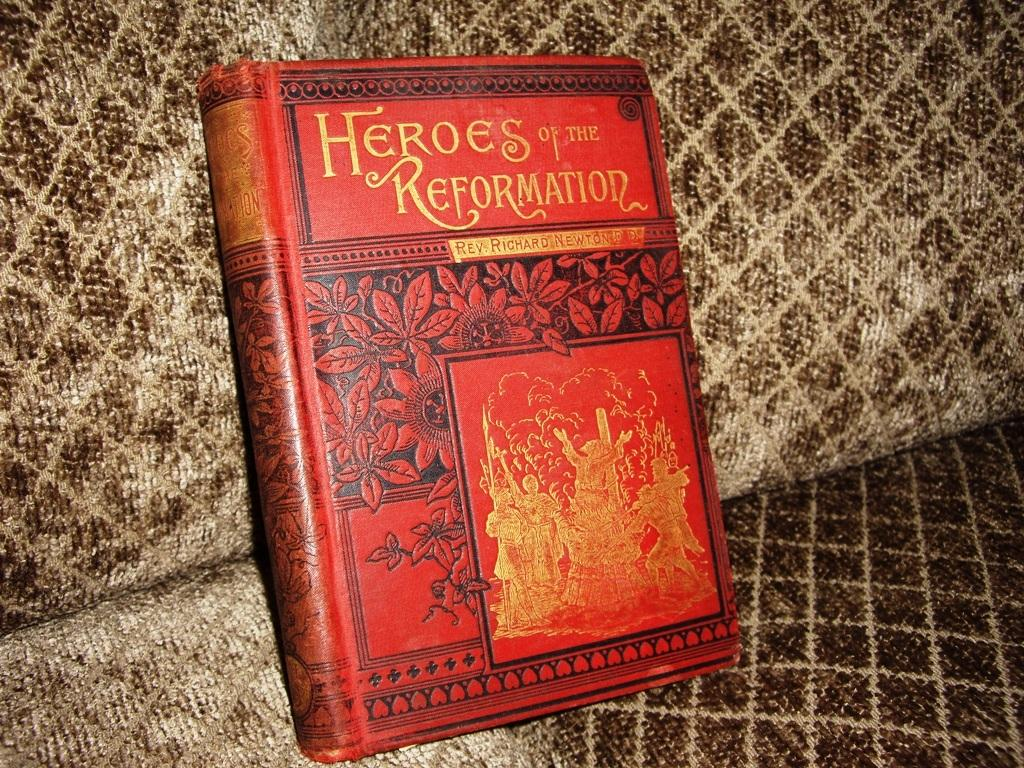<image>
Provide a brief description of the given image. a book that is titled 'heroes of the reformation' 